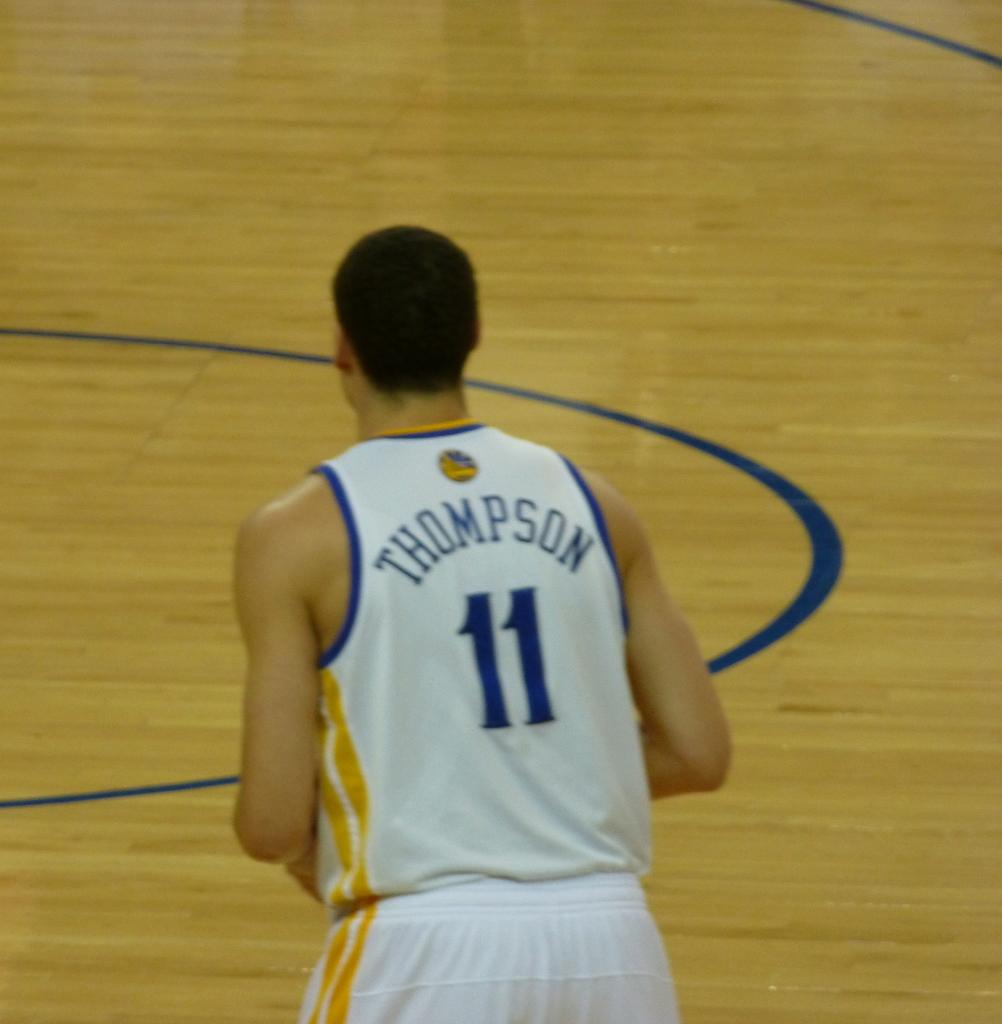What is the main subject of the image? There is a man standing in the image. What is the man wearing in the image? The man is wearing a white vest. Are there any specific details on the vest? Yes, the vest has a name and a number on it. How does the man feel about the level of comfort provided by the floor in the image? There is no information about the floor or the man's feelings about it in the image. 